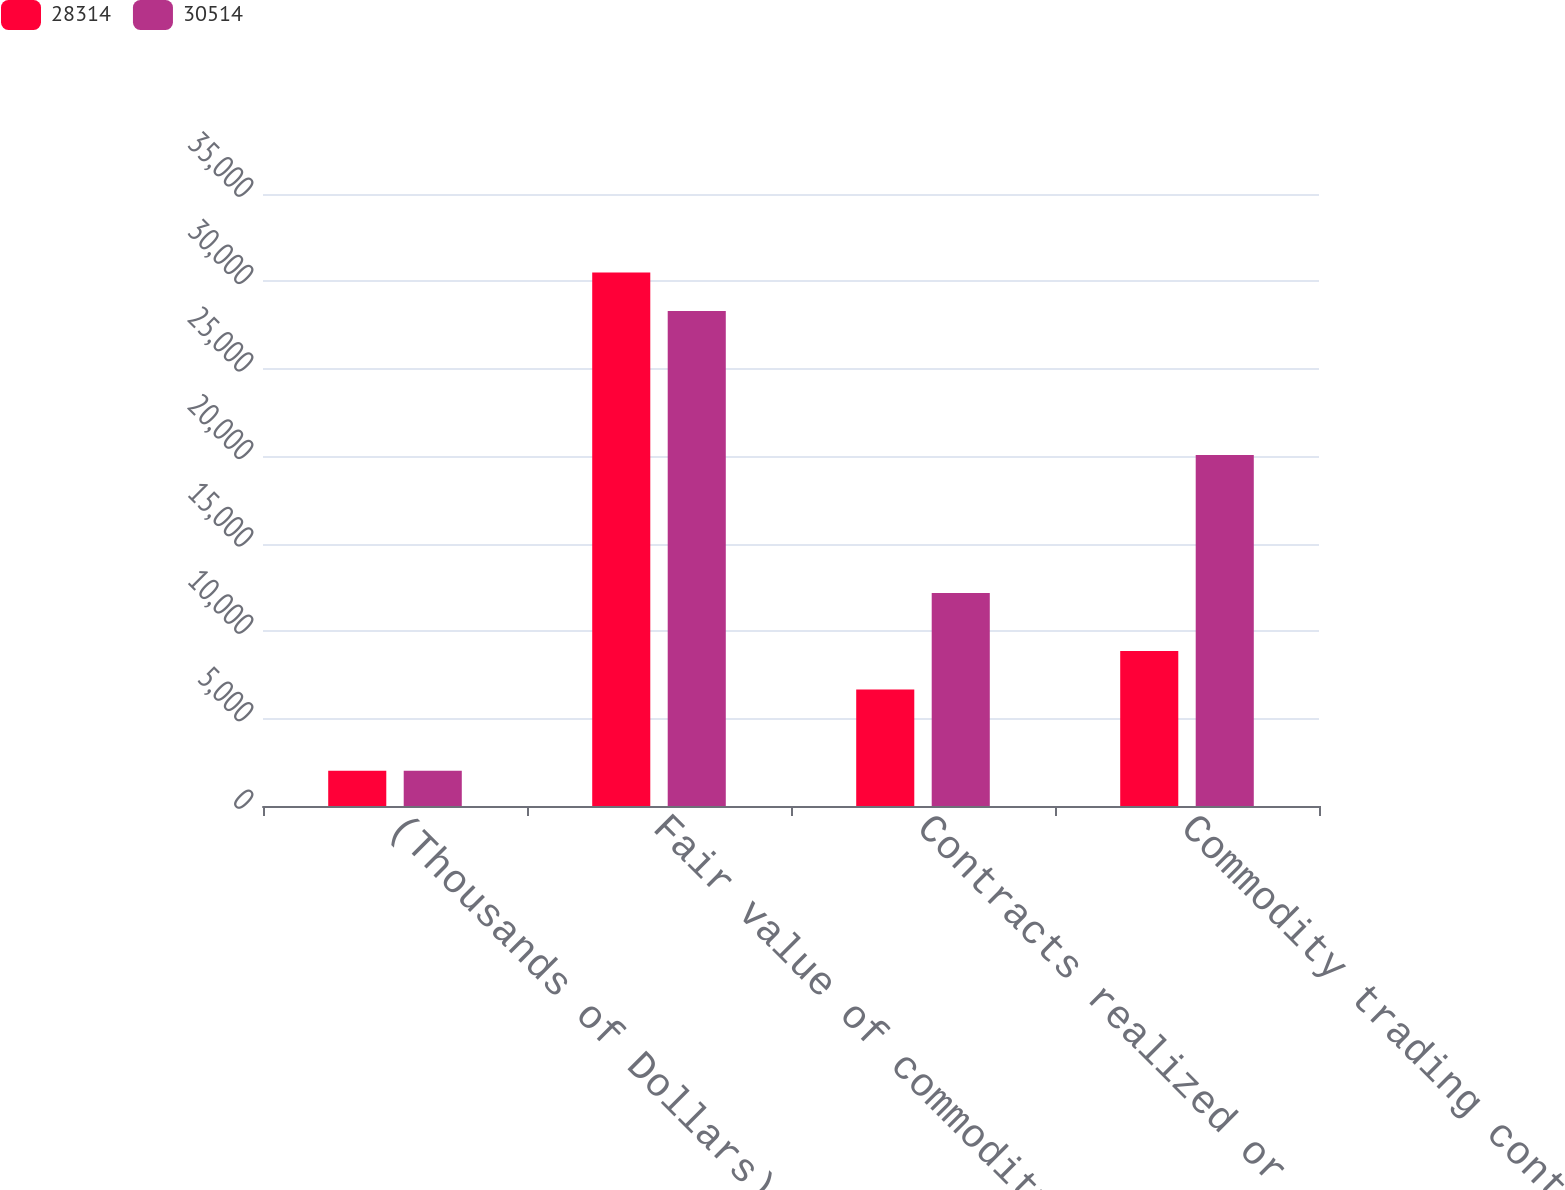<chart> <loc_0><loc_0><loc_500><loc_500><stacked_bar_chart><ecel><fcel>(Thousands of Dollars)<fcel>Fair value of commodity<fcel>Contracts realized or settled<fcel>Commodity trading contract<nl><fcel>28314<fcel>2013<fcel>30514<fcel>6665<fcel>8865<nl><fcel>30514<fcel>2012<fcel>28314<fcel>12185<fcel>20075<nl></chart> 